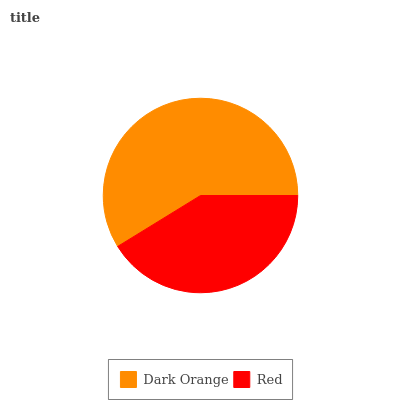Is Red the minimum?
Answer yes or no. Yes. Is Dark Orange the maximum?
Answer yes or no. Yes. Is Red the maximum?
Answer yes or no. No. Is Dark Orange greater than Red?
Answer yes or no. Yes. Is Red less than Dark Orange?
Answer yes or no. Yes. Is Red greater than Dark Orange?
Answer yes or no. No. Is Dark Orange less than Red?
Answer yes or no. No. Is Dark Orange the high median?
Answer yes or no. Yes. Is Red the low median?
Answer yes or no. Yes. Is Red the high median?
Answer yes or no. No. Is Dark Orange the low median?
Answer yes or no. No. 